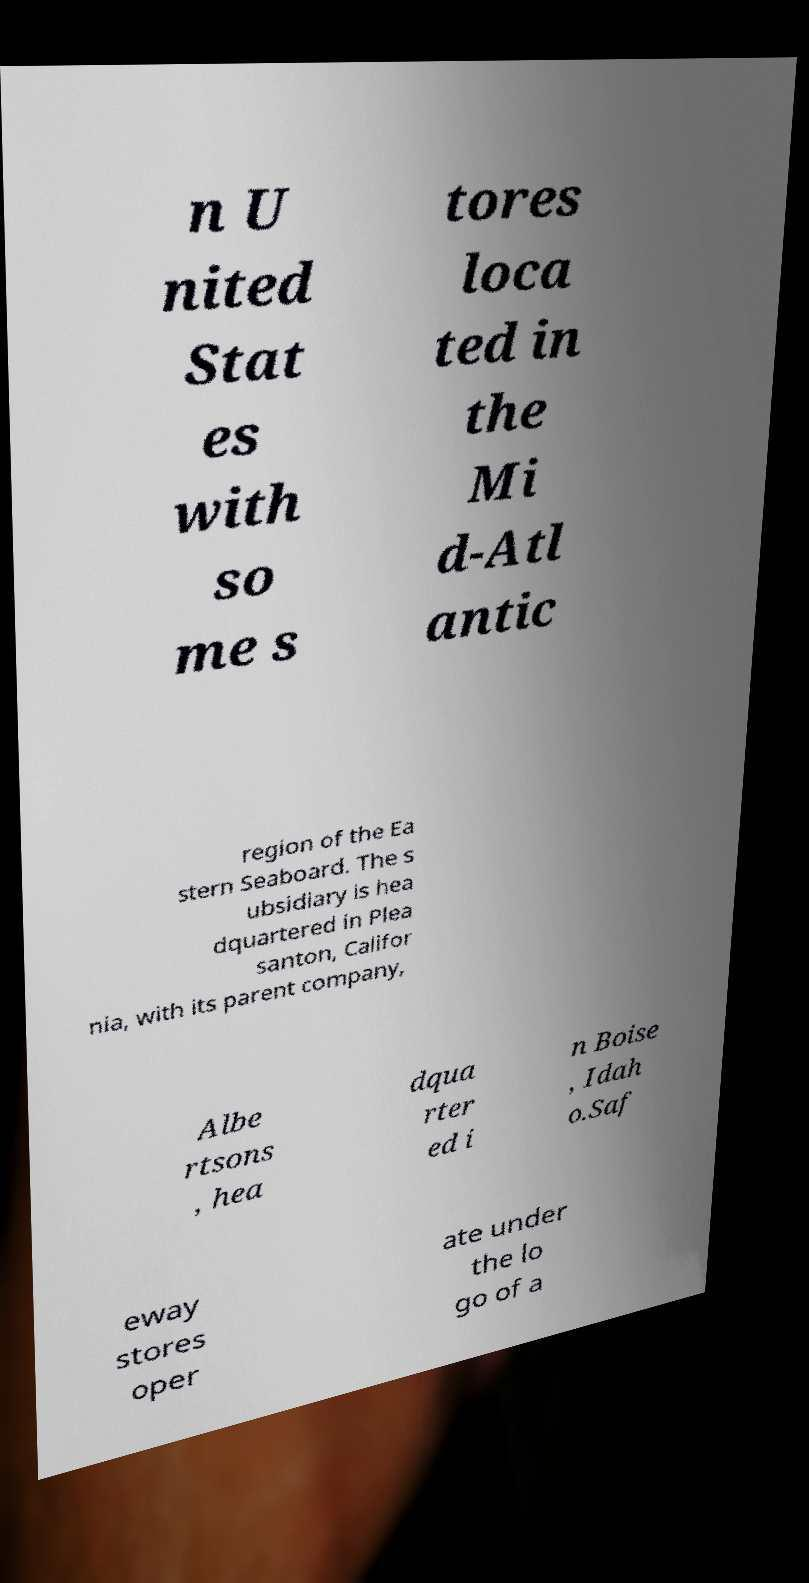Could you assist in decoding the text presented in this image and type it out clearly? n U nited Stat es with so me s tores loca ted in the Mi d-Atl antic region of the Ea stern Seaboard. The s ubsidiary is hea dquartered in Plea santon, Califor nia, with its parent company, Albe rtsons , hea dqua rter ed i n Boise , Idah o.Saf eway stores oper ate under the lo go of a 